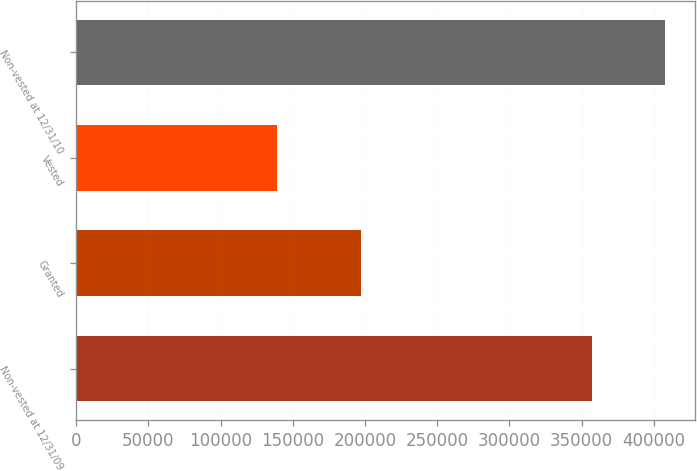Convert chart. <chart><loc_0><loc_0><loc_500><loc_500><bar_chart><fcel>Non-vested at 12/31/09<fcel>Granted<fcel>Vested<fcel>Non-vested at 12/31/10<nl><fcel>357063<fcel>197074<fcel>139163<fcel>407861<nl></chart> 